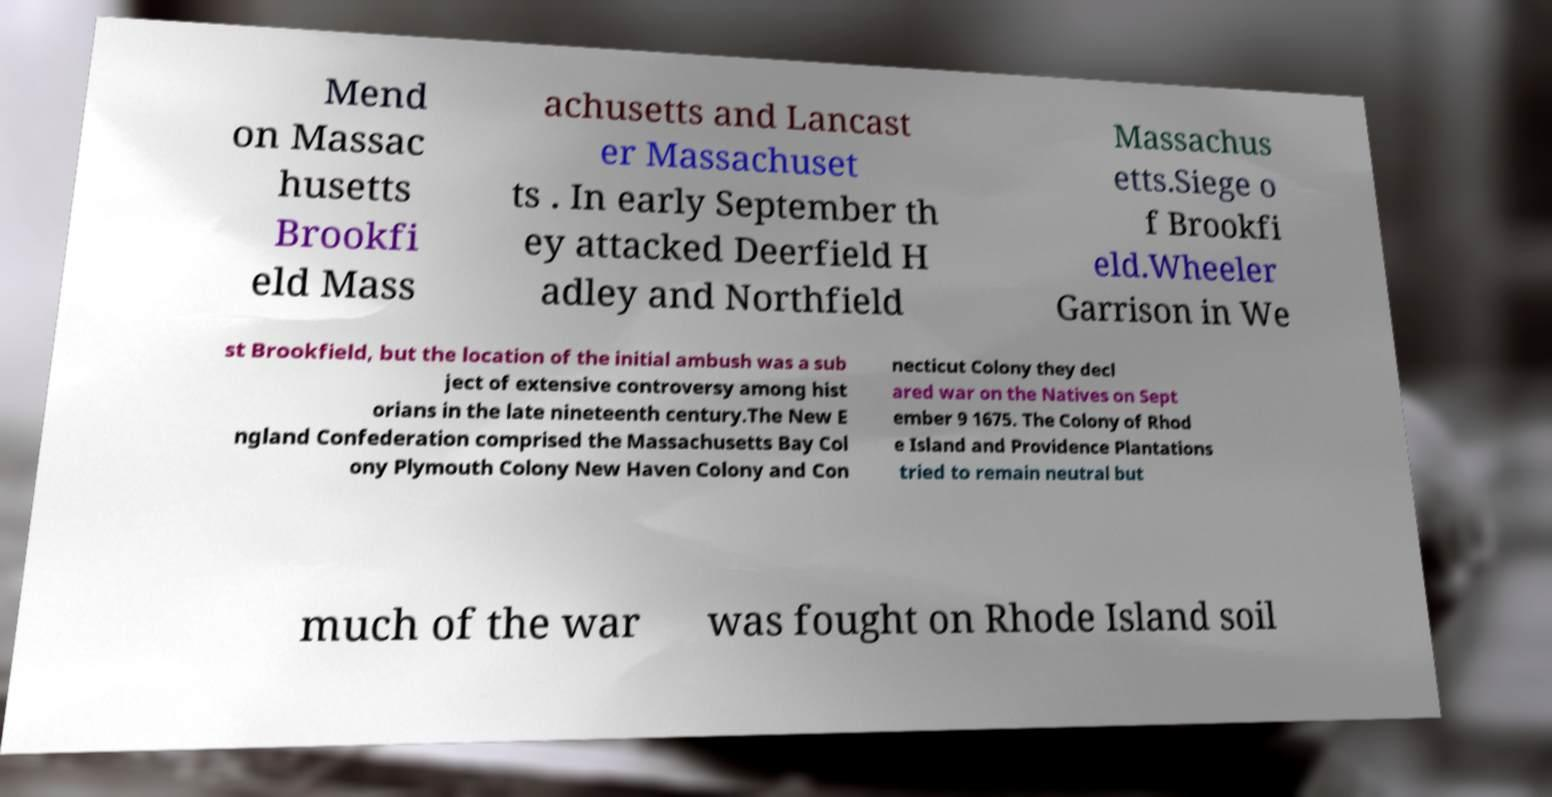I need the written content from this picture converted into text. Can you do that? Mend on Massac husetts Brookfi eld Mass achusetts and Lancast er Massachuset ts . In early September th ey attacked Deerfield H adley and Northfield Massachus etts.Siege o f Brookfi eld.Wheeler Garrison in We st Brookfield, but the location of the initial ambush was a sub ject of extensive controversy among hist orians in the late nineteenth century.The New E ngland Confederation comprised the Massachusetts Bay Col ony Plymouth Colony New Haven Colony and Con necticut Colony they decl ared war on the Natives on Sept ember 9 1675. The Colony of Rhod e Island and Providence Plantations tried to remain neutral but much of the war was fought on Rhode Island soil 